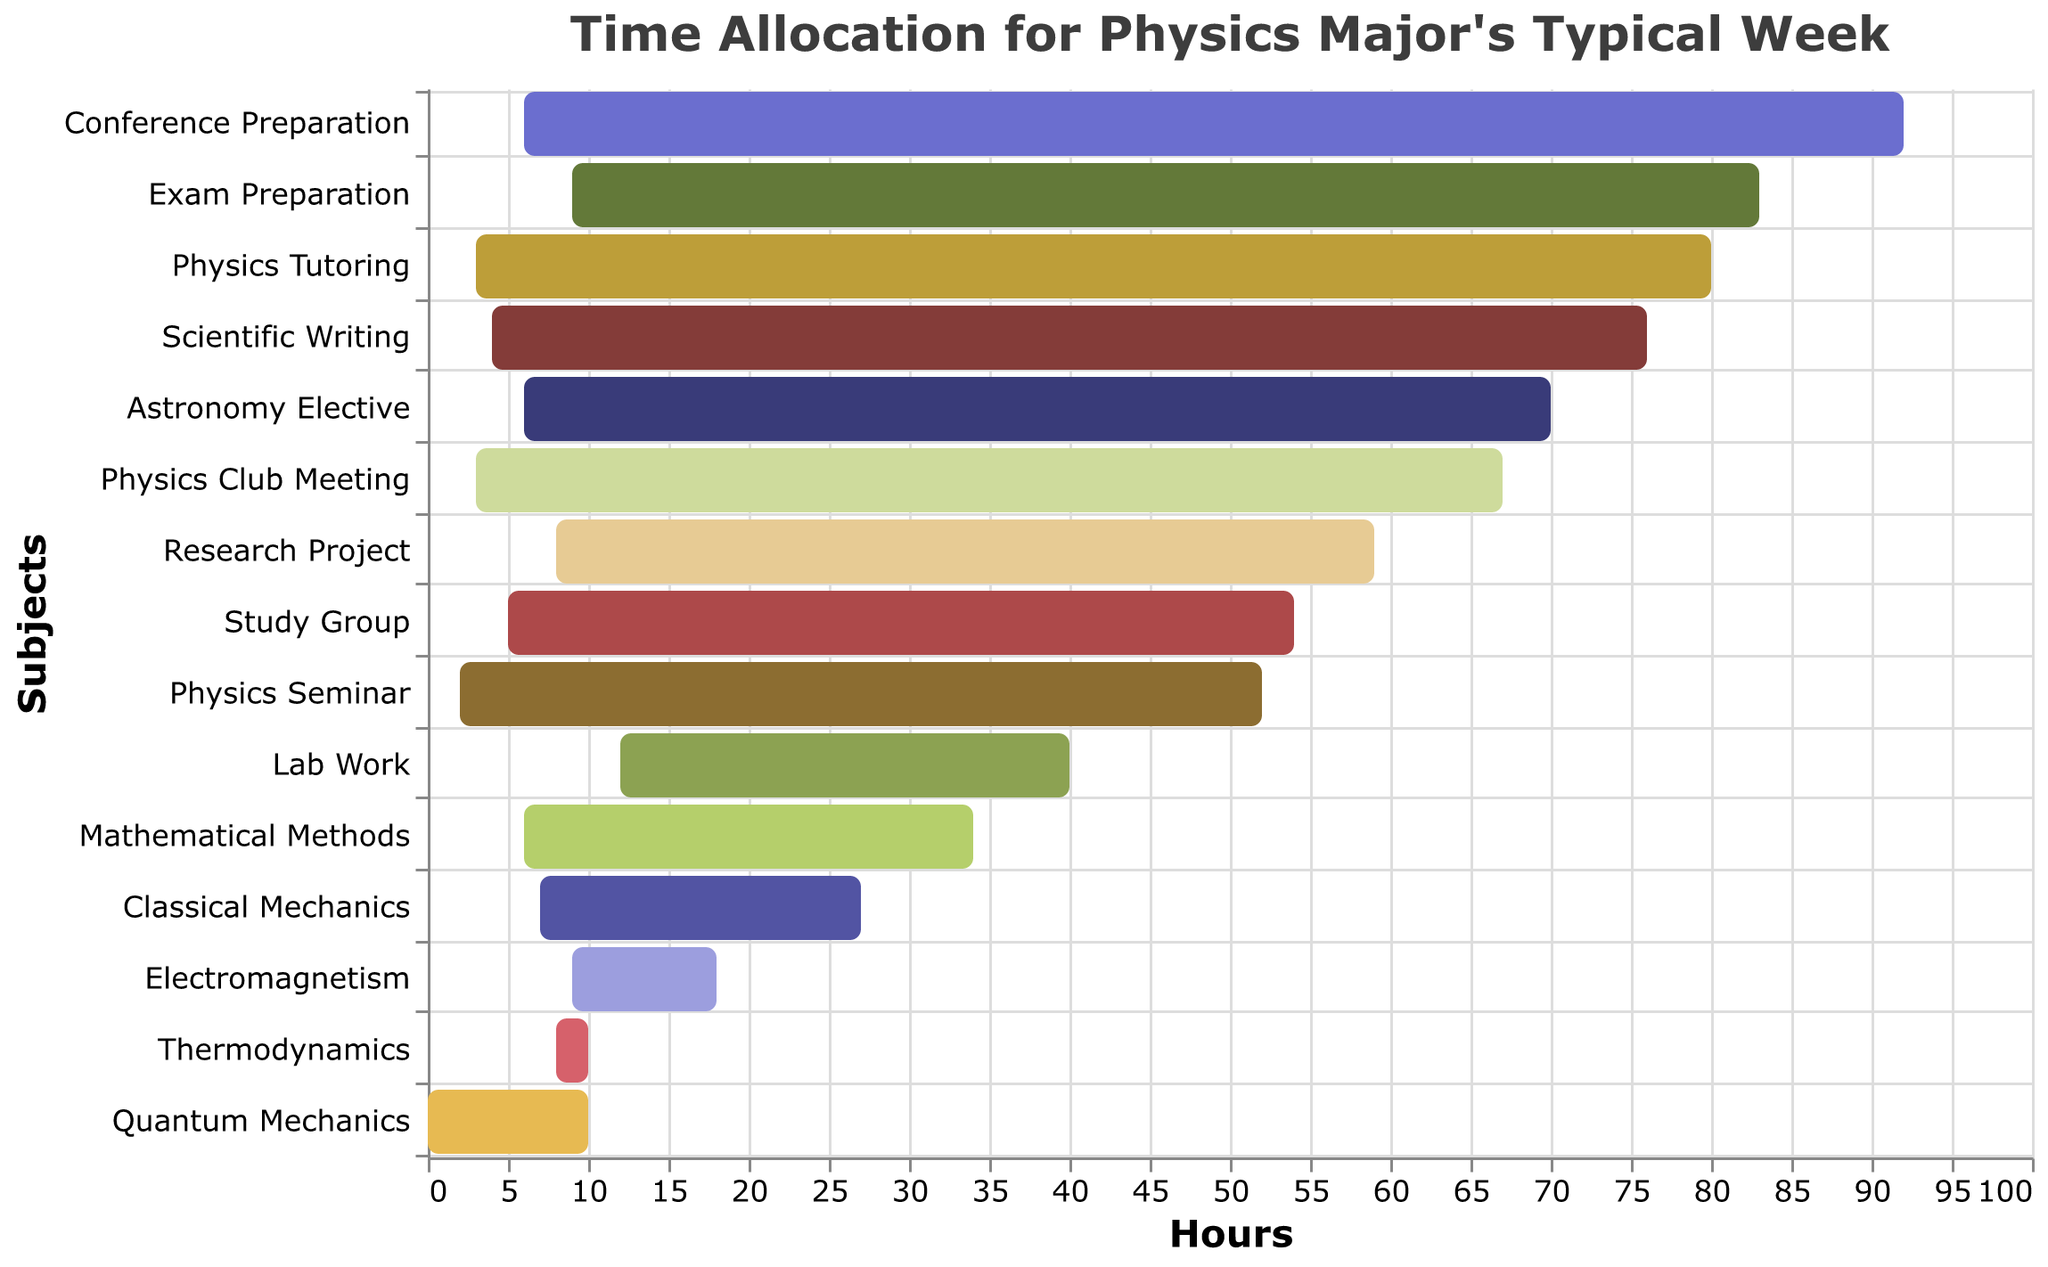What's the duration of time spent on Quantum Mechanics? On the Gantt chart, the bar labeled "Quantum Mechanics" extends from hour 0 to hour 10. Therefore, the duration is easily identified as 10 hours.
Answer: 10 hours Which subjects have a duration equal to 6 hours? Check the length of the bars in the chart. The subjects with bars extending over 6 hours are "Mathematical Methods," "Astronomy Elective," and "Conference Preparation."
Answer: Mathematical Methods, Astronomy Elective, Conference Preparation During which time interval is "Lab Work" scheduled? The "Lab Work" bar starts at hour 40 and ends at hour 52. Therefore, the interval is 40 to 52 hours.
Answer: 40 to 52 hours Which subject takes more time, "Classical Mechanics" or "Electromagnetism"? Compare the lengths of the bars corresponding to each subject. "Classical Mechanics" has a duration of 7 hours while "Electromagnetism" has a duration of 9 hours. Clearly, "Electromagnetism" takes more time.
Answer: Electromagnetism What is the total time spent on "Physics Club Meeting" and "Physics Tutoring"? Add the duration of "Physics Club Meeting" (3 hours) and "Physics Tutoring" (3 hours). 3 + 3 = 6 hours.
Answer: 6 hours How many hours into the week does "Exam Preparation" start? Locate the start point of the "Exam Preparation" bar which begins at hour 83.
Answer: 83 hours Which subject finishes the earliest? The subject that finishes the earliest is the one with the shortest duration starting from the earliest start time. "Quantum Mechanics" starts at hour 0 and finishes at hour 10. It finishes the earliest among all subjects.
Answer: Quantum Mechanics Between which two subjects does "Physics Seminar" lie time-wise? "Physics Seminar" starts at hour 52 and ends at hour 54. It lies between "Lab Work" (which ends at hour 52) and "Study Group" (which starts at hour 54).
Answer: Lab Work and Study Group Which subject extends the longest in terms of duration on the Gantt chart? Check the length of all bars. "Lab Work" has the longest continuous bar with a duration of 12 hours.
Answer: Lab Work 